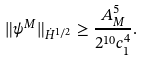<formula> <loc_0><loc_0><loc_500><loc_500>\| \psi ^ { M } \| _ { \dot { H } ^ { 1 / 2 } } \geq \frac { A _ { M } ^ { 5 } } { 2 ^ { 1 0 } c _ { 1 } ^ { 4 } } .</formula> 